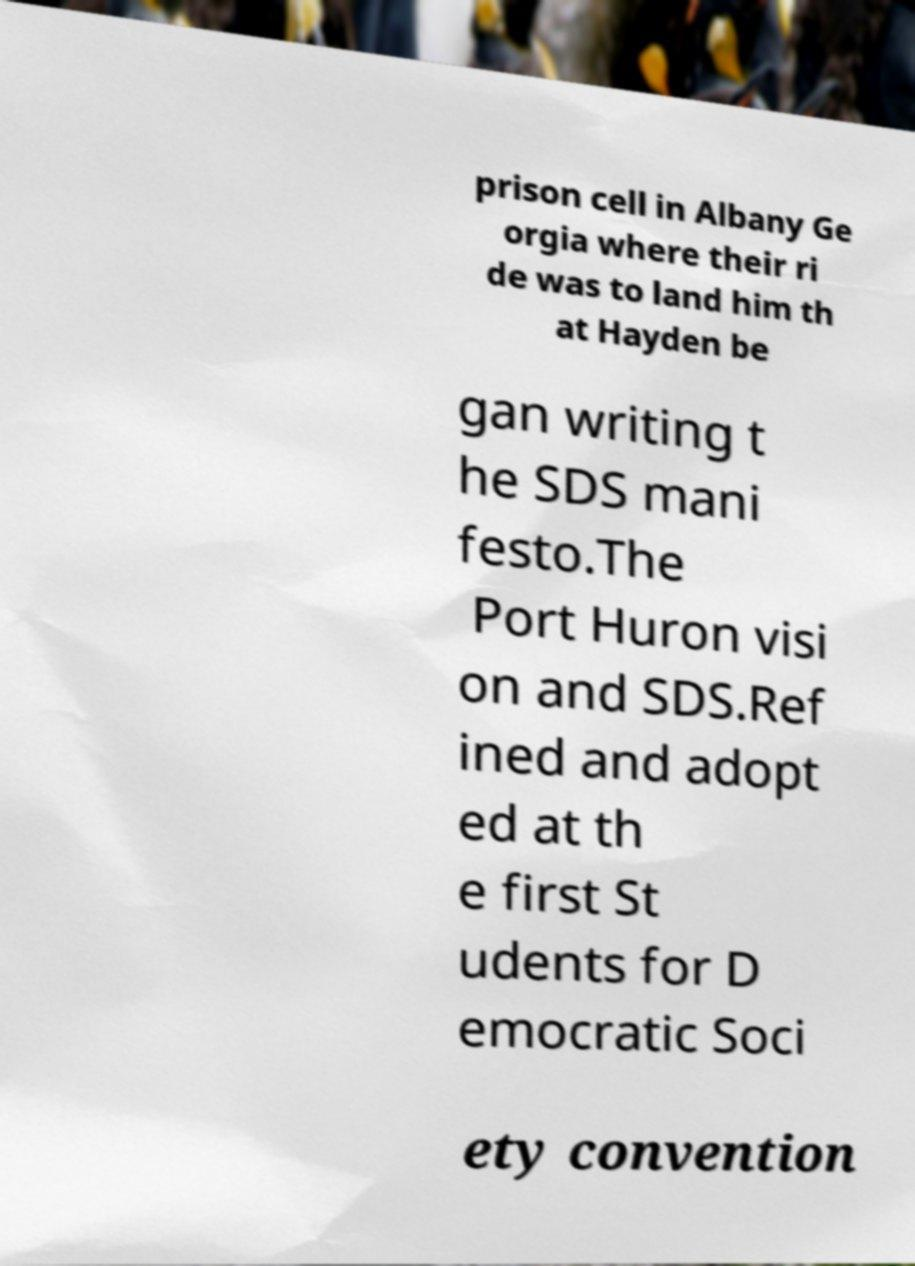For documentation purposes, I need the text within this image transcribed. Could you provide that? prison cell in Albany Ge orgia where their ri de was to land him th at Hayden be gan writing t he SDS mani festo.The Port Huron visi on and SDS.Ref ined and adopt ed at th e first St udents for D emocratic Soci ety convention 